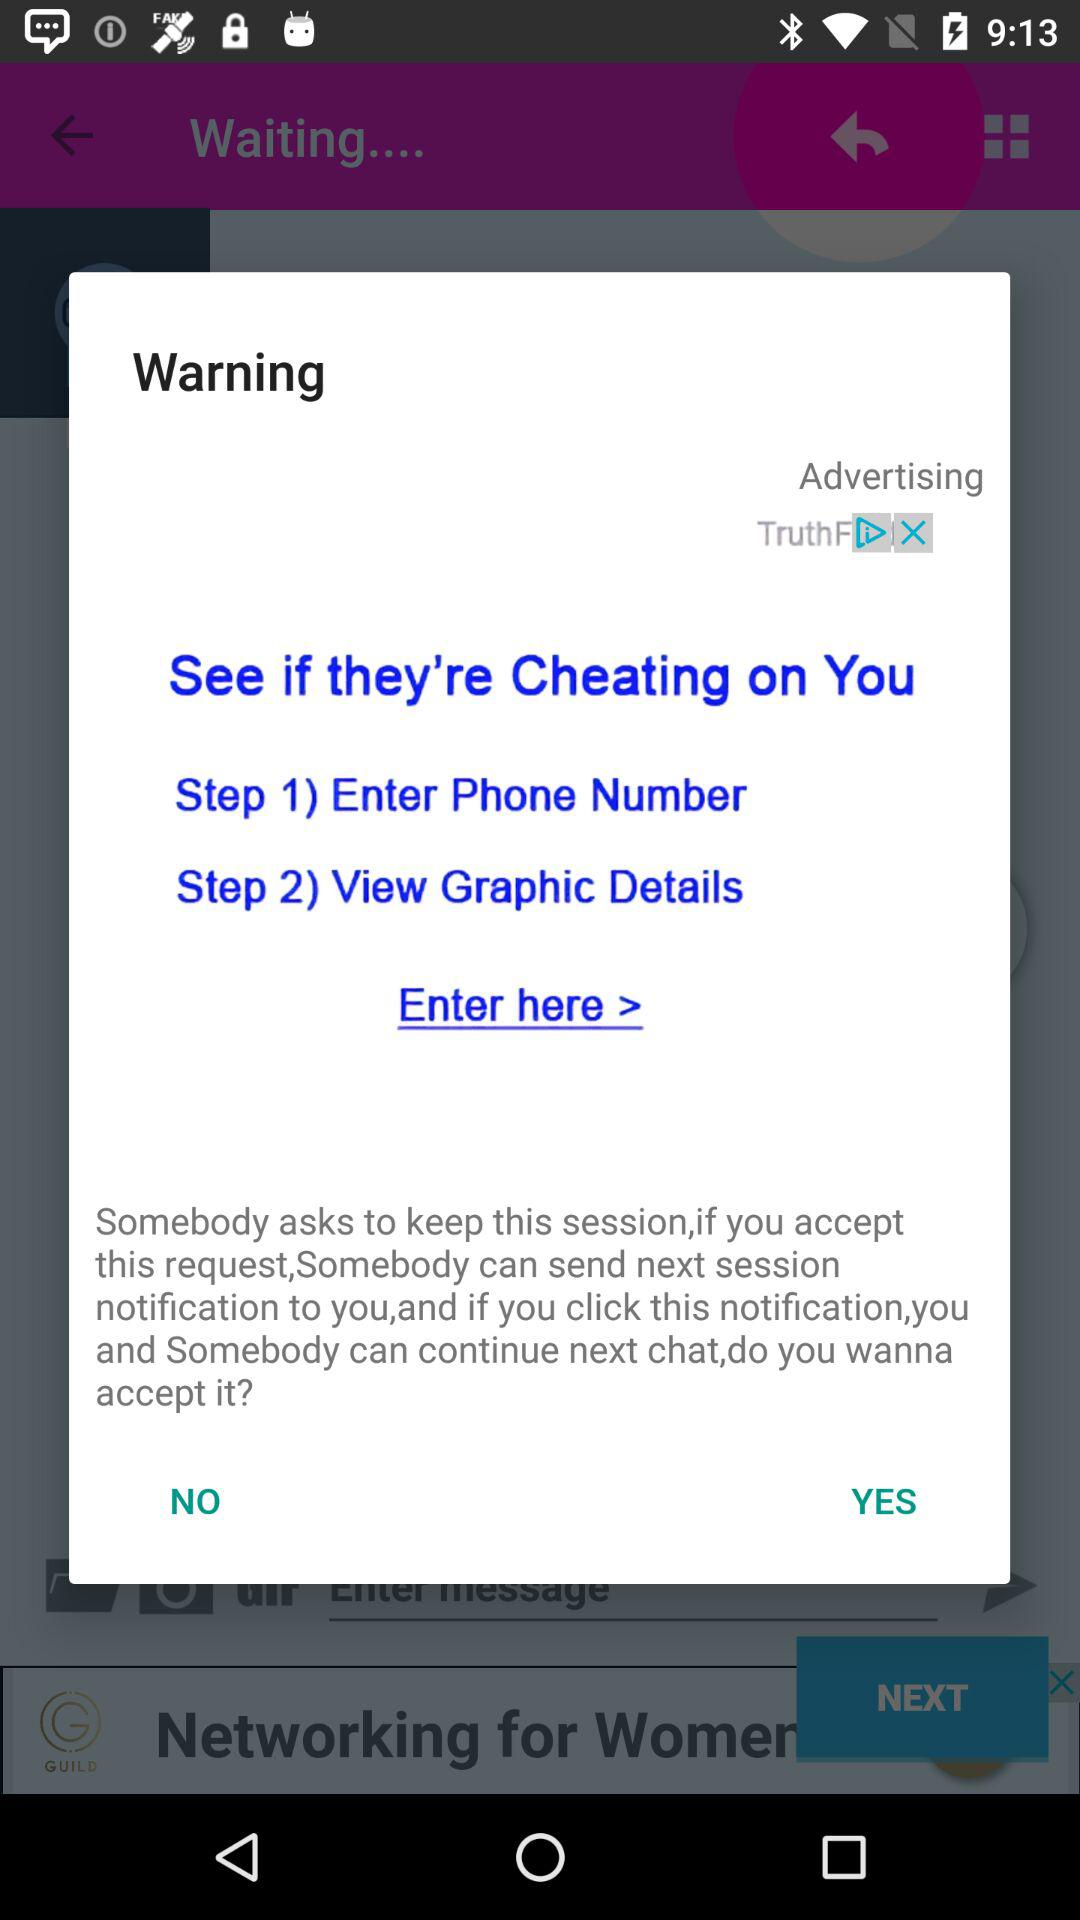How many steps are there in the process?
Answer the question using a single word or phrase. 2 